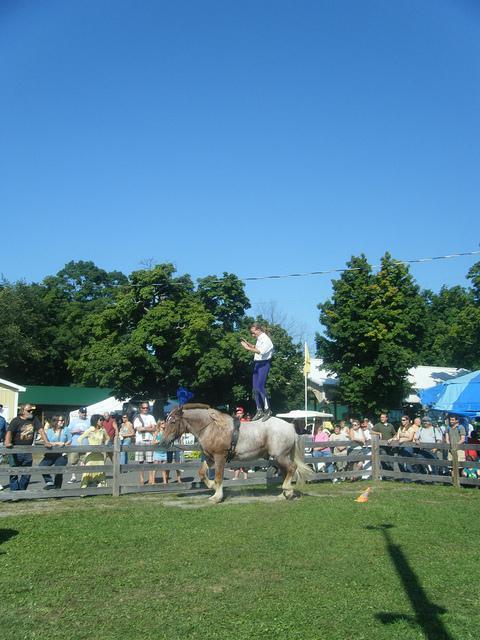How many horses?
Give a very brief answer. 1. How many horses are eating grass?
Give a very brief answer. 0. How many people are there?
Give a very brief answer. 2. 